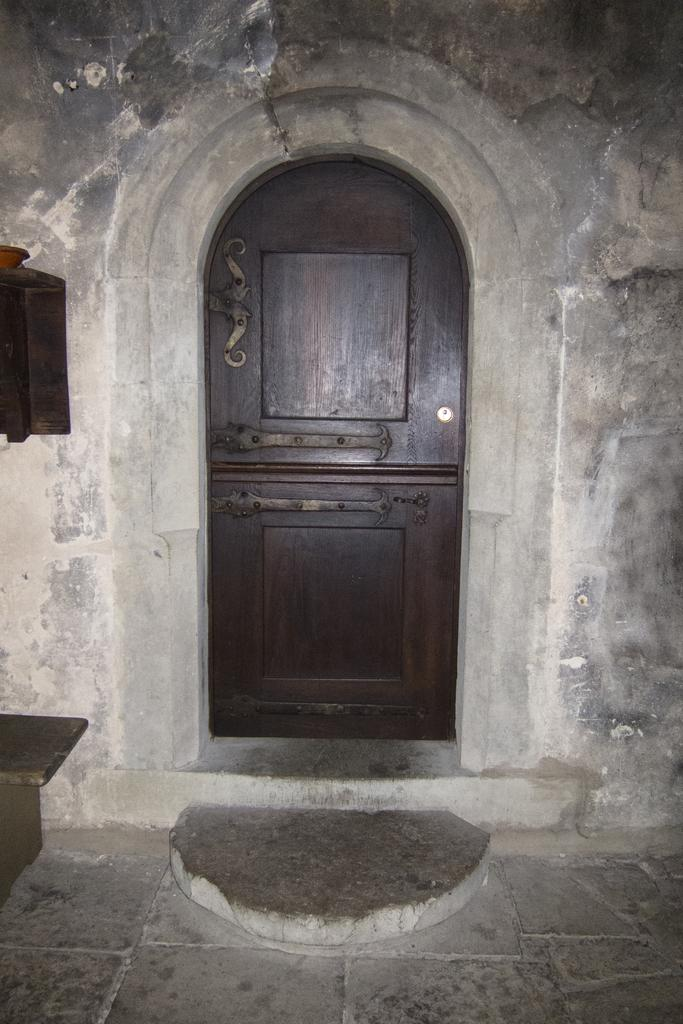What type of structure can be seen in the image? There is a door in the image. What material is used for the wall in the image? There is a stone wall in the image. What type of pest can be seen crawling on the door in the image? There are no pests visible in the image; it only features a door and a stone wall. What is the tray used for in the image? There is no tray present in the image. 